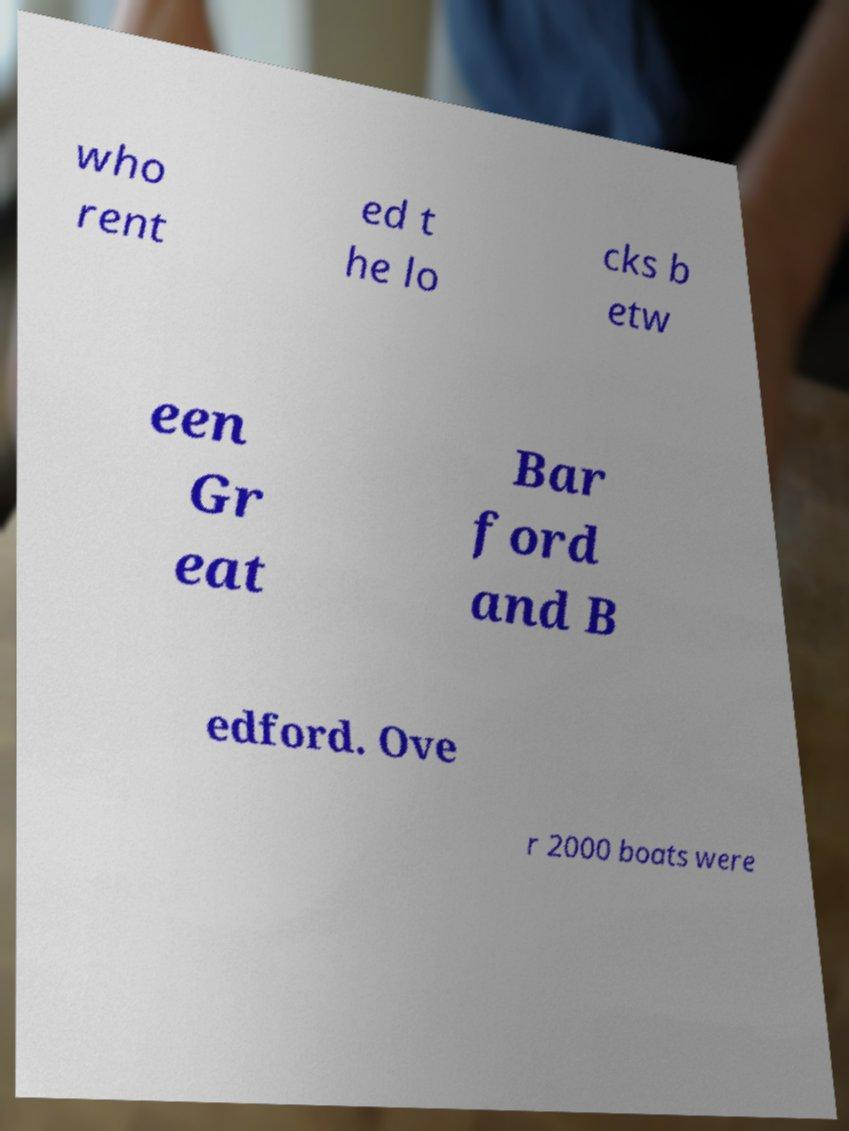Please identify and transcribe the text found in this image. who rent ed t he lo cks b etw een Gr eat Bar ford and B edford. Ove r 2000 boats were 